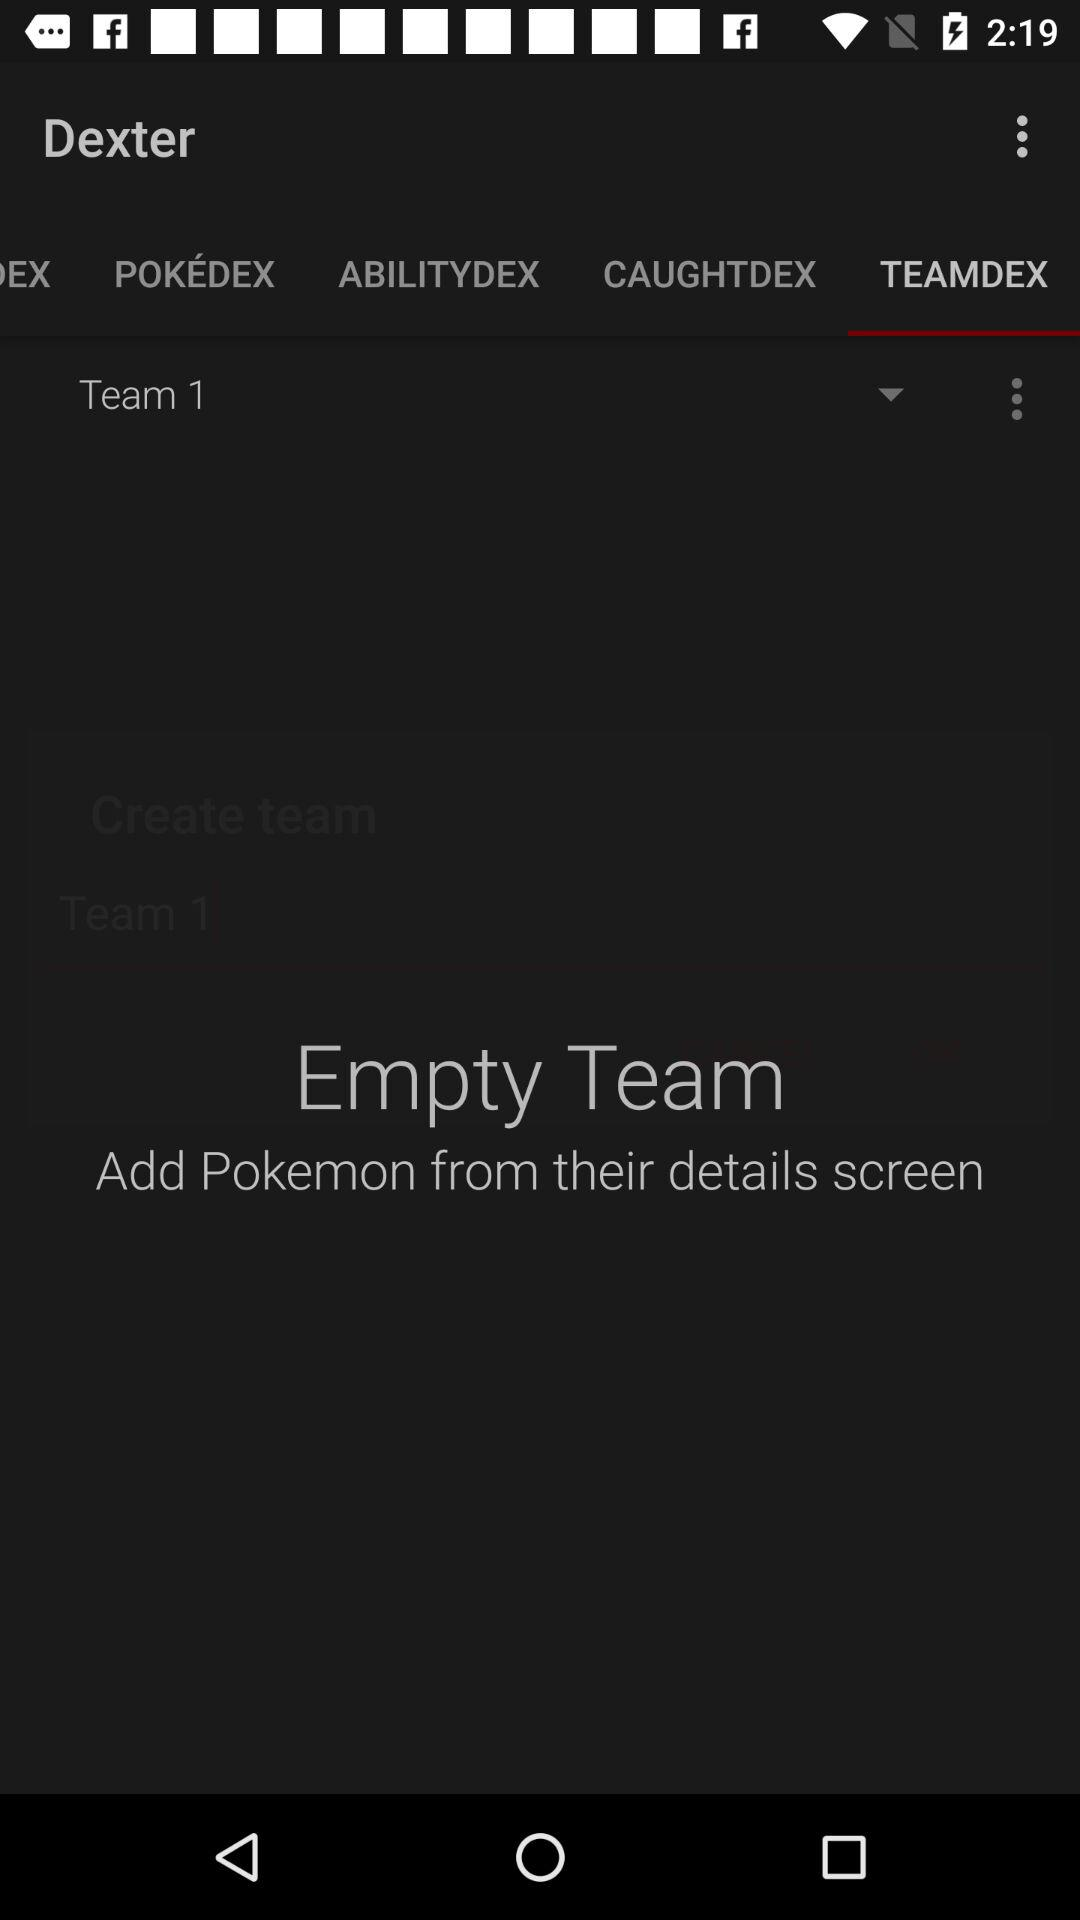Which team is shown? The shown team is "Team 1". 